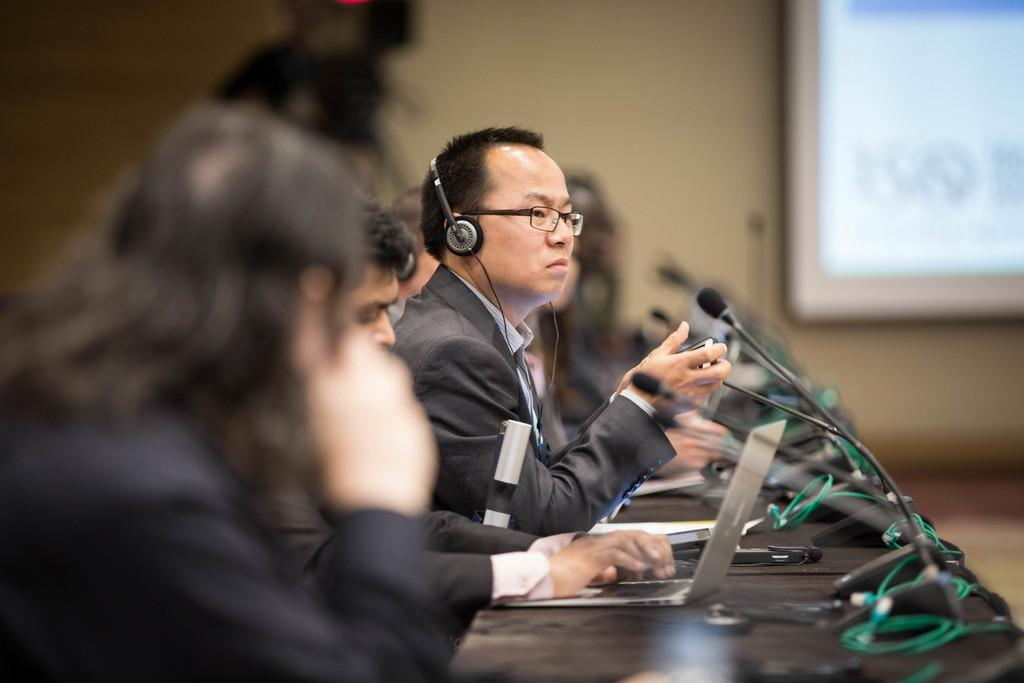What are the persons in the image doing? The persons in the image are sitting on chairs. What is on the table in the image? There is a laptop, cables, papers, and a microphone on the table. What can be seen in the background of the image? There is a wall and a screen in the background of the image. What type of cloud can be seen in the image? There is no cloud visible in the image; it features a wall and a screen in the background. What texture can be felt on the things on the table? The question is too vague to answer definitively, as it does not specify which "things" on the table we are referring to. However, we can describe the texture of the laptop, cables, papers, and microphone individually if needed. 